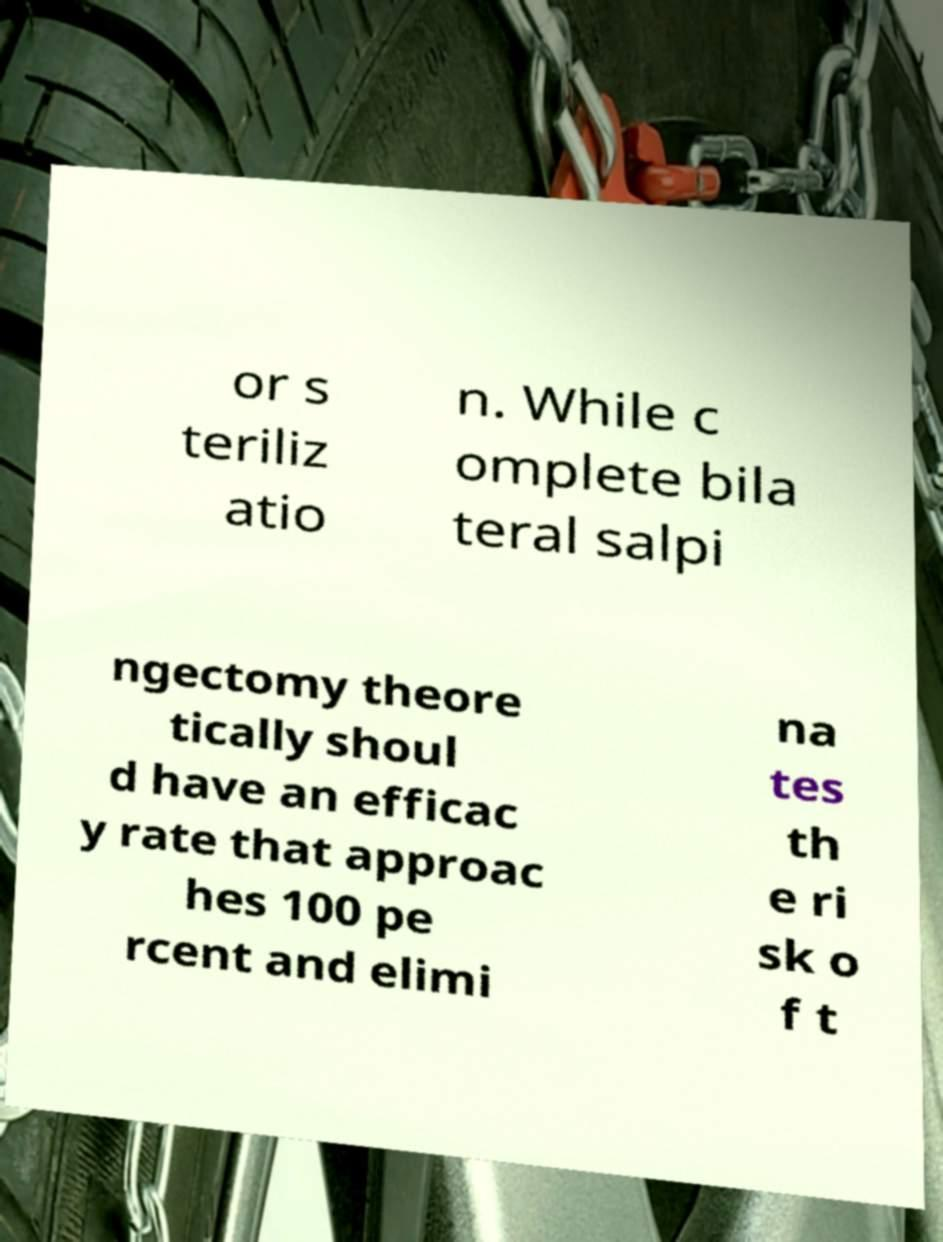Could you assist in decoding the text presented in this image and type it out clearly? or s teriliz atio n. While c omplete bila teral salpi ngectomy theore tically shoul d have an efficac y rate that approac hes 100 pe rcent and elimi na tes th e ri sk o f t 